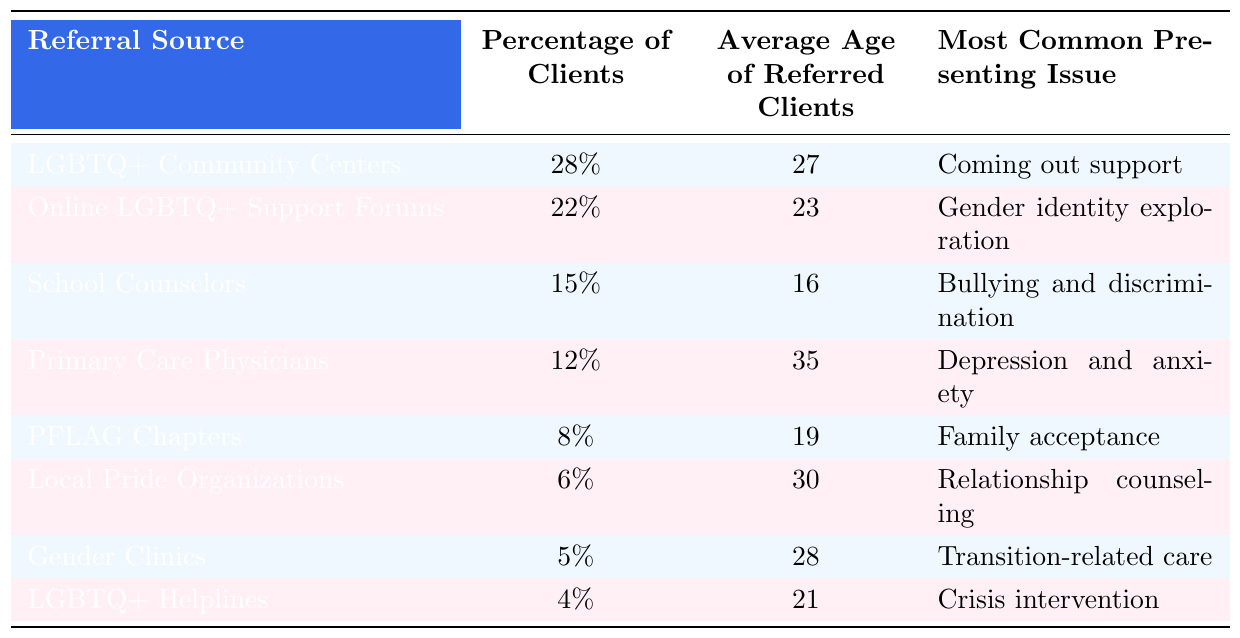What is the most common referral source for LGBTQ+ clients seeking psychological support? The table shows that LGBTQ+ Community Centers have the highest percentage of clients referred at 28%.
Answer: LGBTQ+ Community Centers What percentage of clients are referred by Primary Care Physicians? The table indicates that 12% of clients are referred by Primary Care Physicians.
Answer: 12% What is the average age of clients referred by Online LGBTQ+ Support Forums? The average age of referred clients from Online LGBTQ+ Support Forums is 23 years, as listed in the table.
Answer: 23 Which referral source has the lowest percentage of clients? The lowest percentage of clients referred, according to the table, is from LGBTQ+ Helplines at 4%.
Answer: LGBTQ+ Helplines Is the most common presenting issue for clients referred by School Counselors related to mental health? The table states that the most common presenting issue for clients referred by School Counselors is bullying and discrimination, which can be related to mental health challenges. Therefore, the answer is yes.
Answer: Yes What is the average age of clients referred by LGBTQ+ Community Centers compared to those referred by PFLAG Chapters? The average age for clients referred by LGBTQ+ Community Centers is 27, while for PFLAG Chapters it is 19. The difference in average age is 27 - 19 = 8 years.
Answer: 8 years What is the total percentage of clients referred by the top three referral sources? The top three referral sources are LGBTQ+ Community Centers (28%), Online LGBTQ+ Support Forums (22%), and School Counselors (15%). Adding these gives 28 + 22 + 15 = 65%.
Answer: 65% Which presenting issue is most common among clients referred by Gender Clinics? According to the table, the most common presenting issue for clients referred by Gender Clinics is transition-related care.
Answer: Transition-related care If the average age of clients referred by Primary Care Physicians is 35, what is the difference in age compared to the average age of clients referred by Local Pride Organizations? The average age of clients referred by Local Pride Organizations is 30. The difference is 35 - 30 = 5 years.
Answer: 5 years Which two referral sources have a common presenting issue related to family dynamics? The presenting issues that relate to family dynamics are found under PFLAG Chapters (family acceptance). There are no other referral sources listed with a presenting issue focused on family dynamics, thus the answer is only PFLAG Chapters.
Answer: PFLAG Chapters 